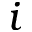Convert formula to latex. <formula><loc_0><loc_0><loc_500><loc_500>i</formula> 